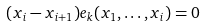Convert formula to latex. <formula><loc_0><loc_0><loc_500><loc_500>( x _ { i } - x _ { i + 1 } ) e _ { k } ( x _ { 1 } , \dots , x _ { i } ) = 0</formula> 